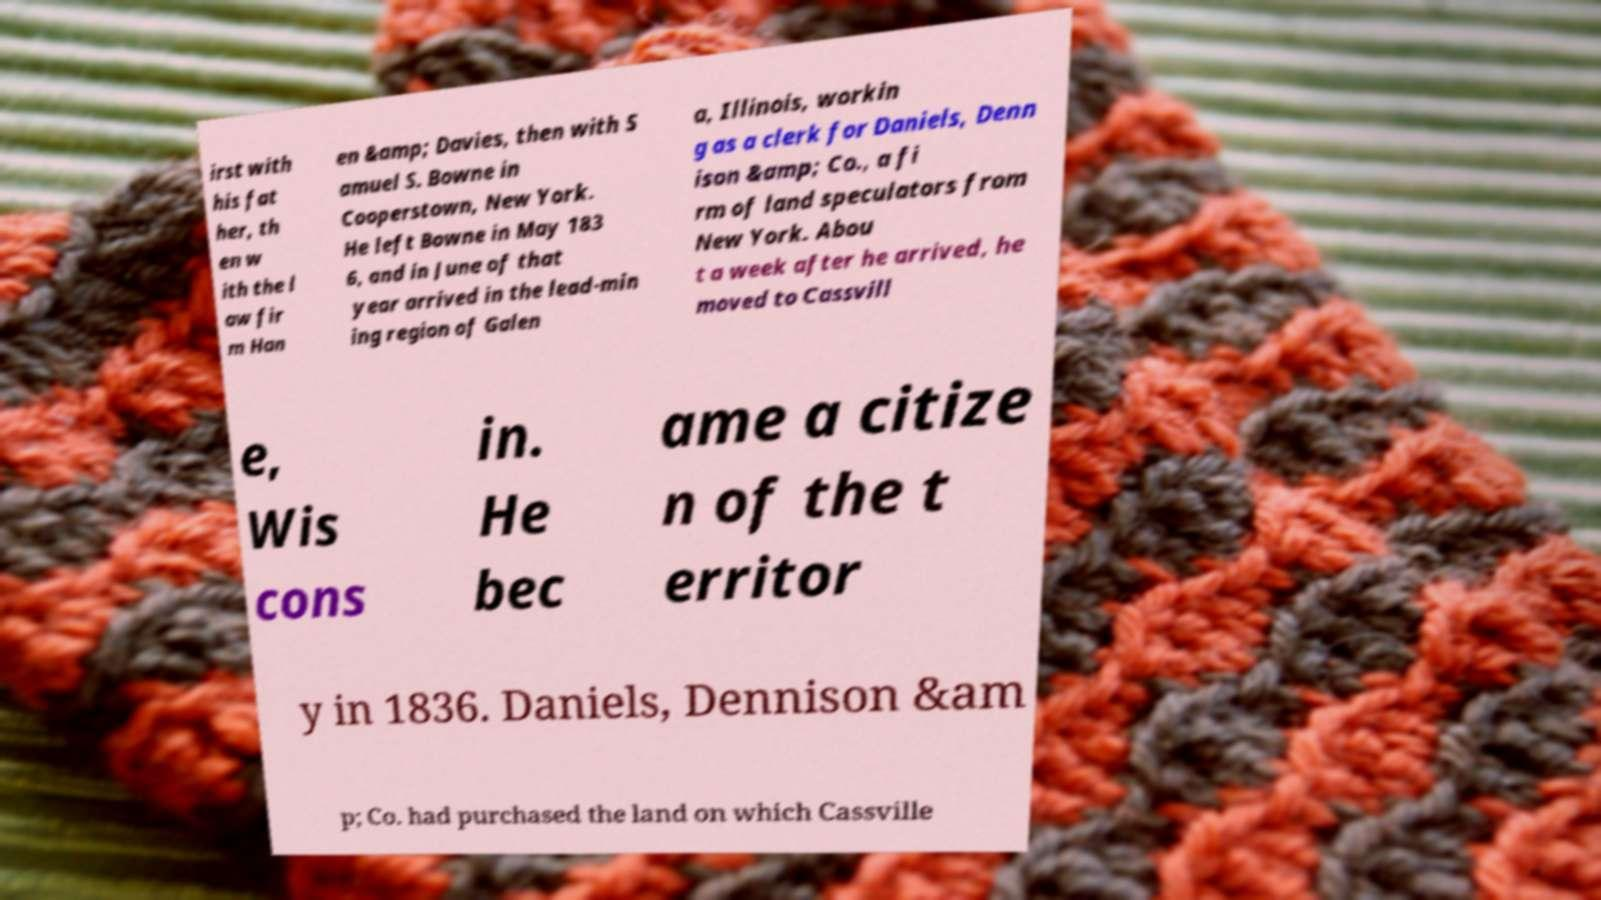Can you read and provide the text displayed in the image?This photo seems to have some interesting text. Can you extract and type it out for me? irst with his fat her, th en w ith the l aw fir m Han en &amp; Davies, then with S amuel S. Bowne in Cooperstown, New York. He left Bowne in May 183 6, and in June of that year arrived in the lead-min ing region of Galen a, Illinois, workin g as a clerk for Daniels, Denn ison &amp; Co., a fi rm of land speculators from New York. Abou t a week after he arrived, he moved to Cassvill e, Wis cons in. He bec ame a citize n of the t erritor y in 1836. Daniels, Dennison &am p; Co. had purchased the land on which Cassville 